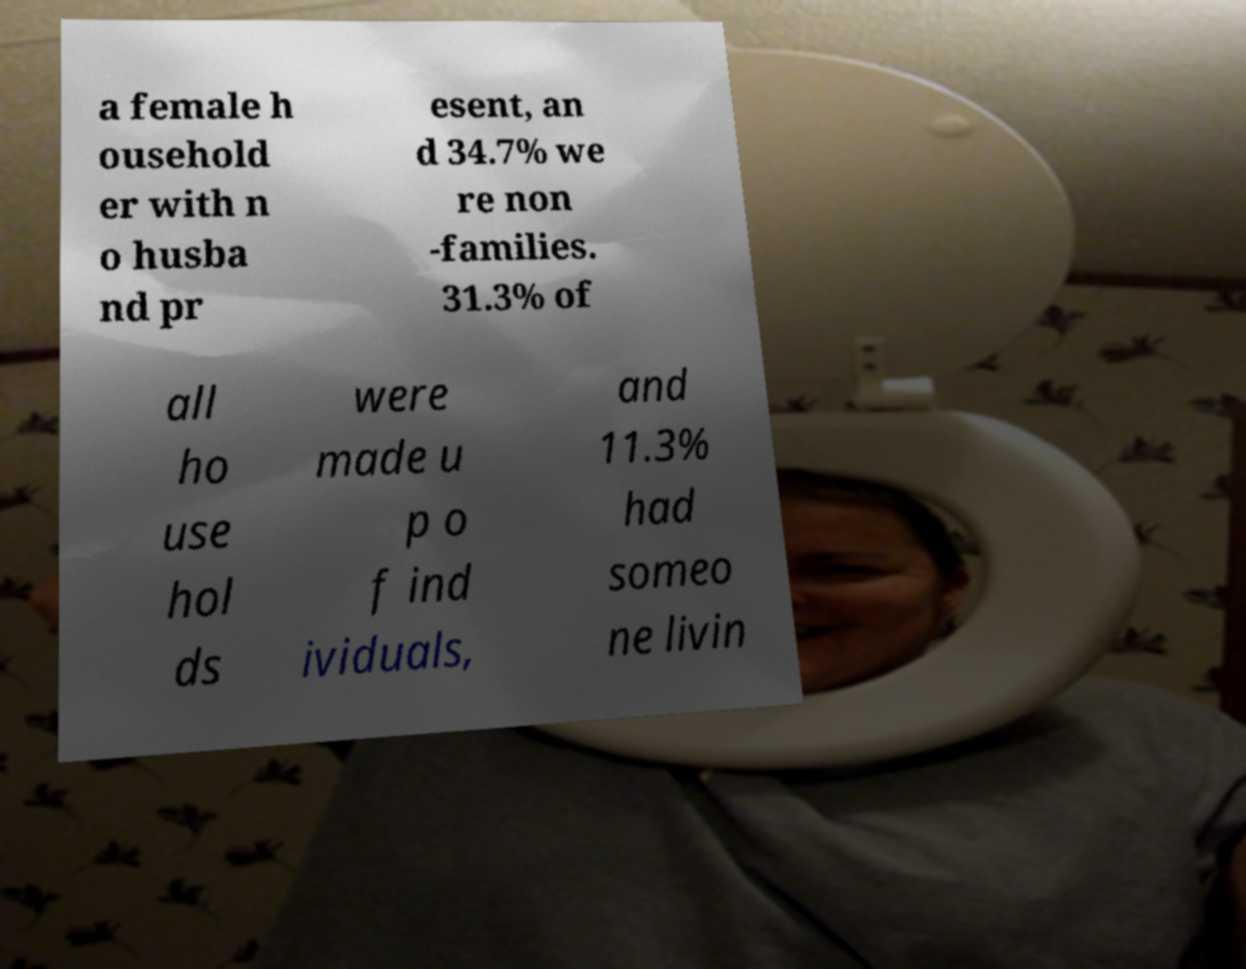For documentation purposes, I need the text within this image transcribed. Could you provide that? a female h ousehold er with n o husba nd pr esent, an d 34.7% we re non -families. 31.3% of all ho use hol ds were made u p o f ind ividuals, and 11.3% had someo ne livin 